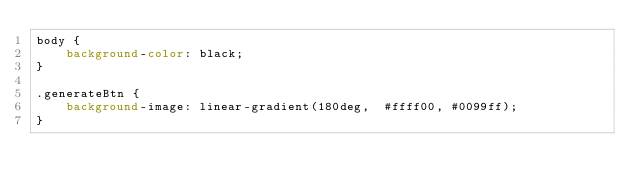<code> <loc_0><loc_0><loc_500><loc_500><_CSS_>body {
	background-color: black;
}

.generateBtn {
	background-image: linear-gradient(180deg,  #ffff00, #0099ff);
}


</code> 